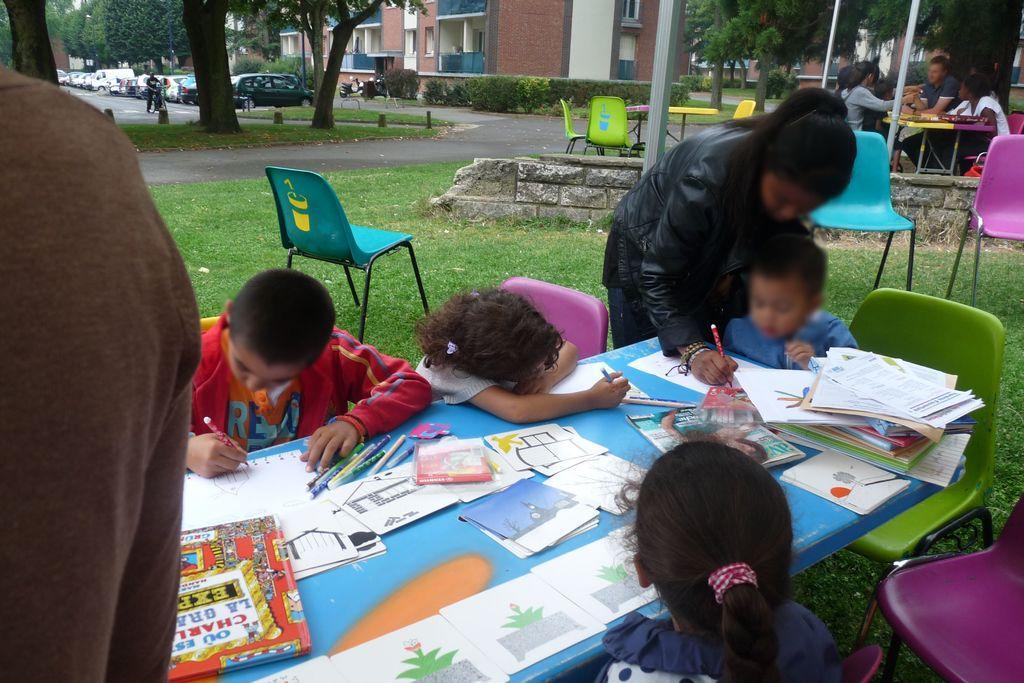Could you give a brief overview of what you see in this image? The picture is taken outdoor in front of the buildings where there are people sitting on the chairs on the right corner of the picture and in the middle of the picture there are children sitting on the chairs and writing something on the table and one woman is standing in black dress and there are trees and vehicles on the road and one person is sitting on the bike. 